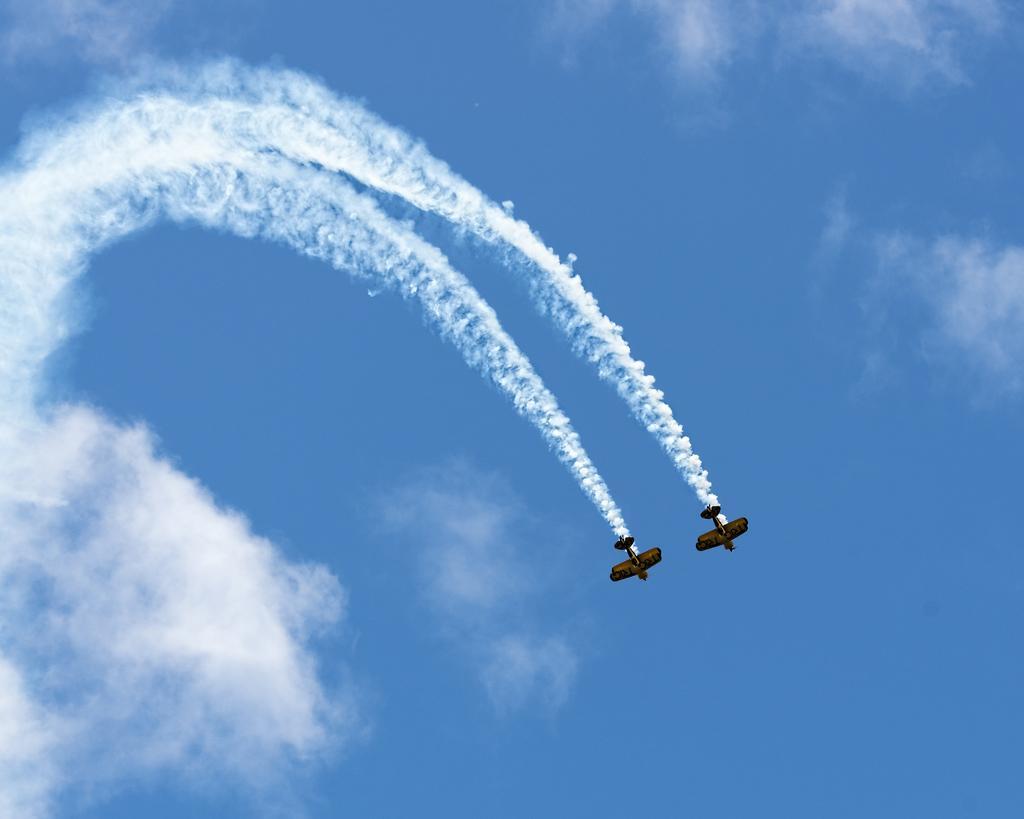Describe this image in one or two sentences. In the given image i can see a airshow and in the background i can see the sky. 